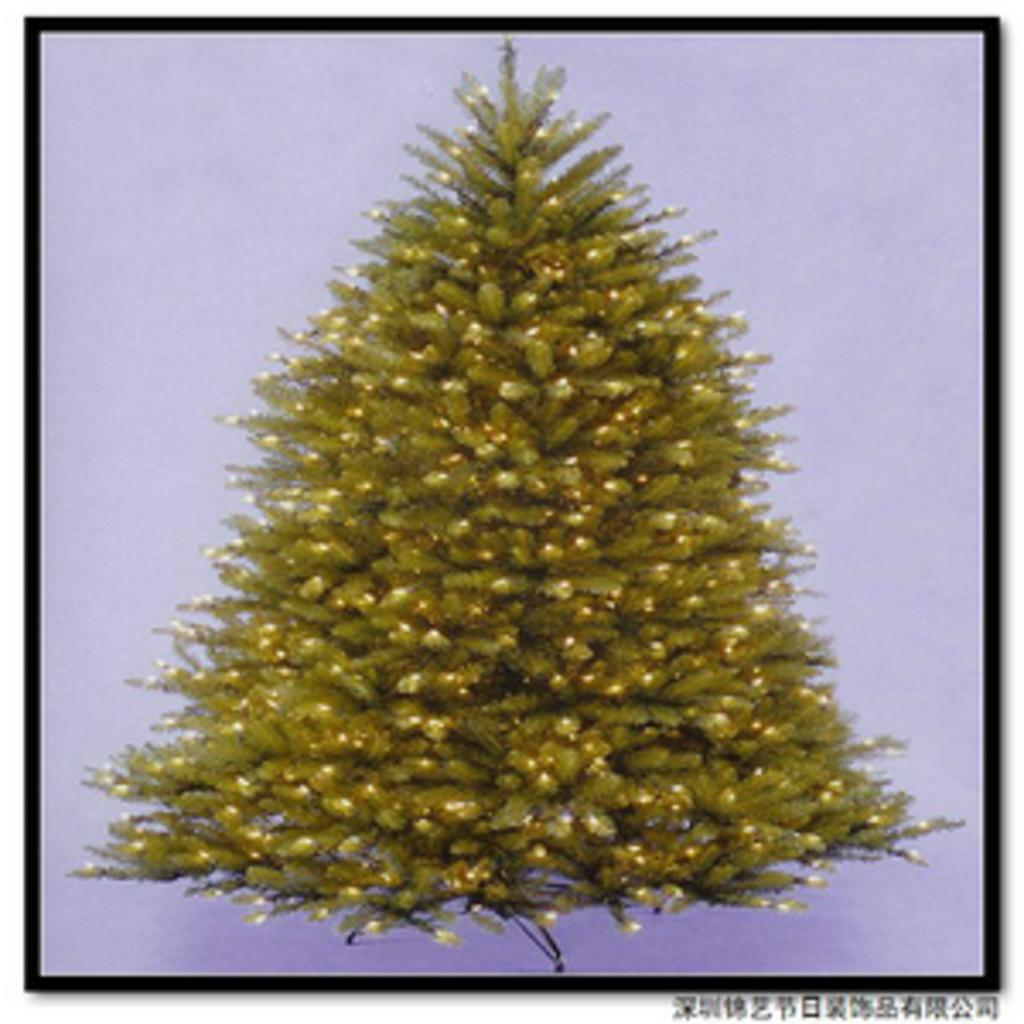What is the main subject of the image? There is a Christmas tree in the image. Where is the Christmas tree located in the image? The Christmas tree is in the center of the image. What type of country is depicted in the image? There is no country depicted in the image; it features a Christmas tree. What kind of game is being played in the image? There is no game being played in the image; it features a Christmas tree. 